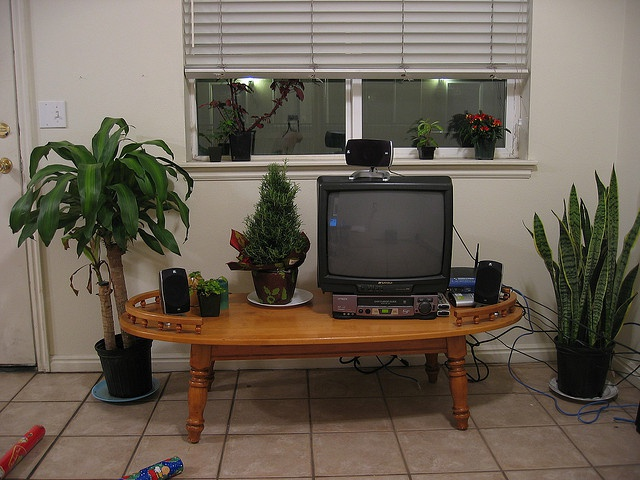Describe the objects in this image and their specific colors. I can see potted plant in gray, black, and darkgreen tones, tv in gray and black tones, potted plant in gray, black, darkgreen, and darkgray tones, potted plant in gray, black, and darkgreen tones, and potted plant in gray and black tones in this image. 